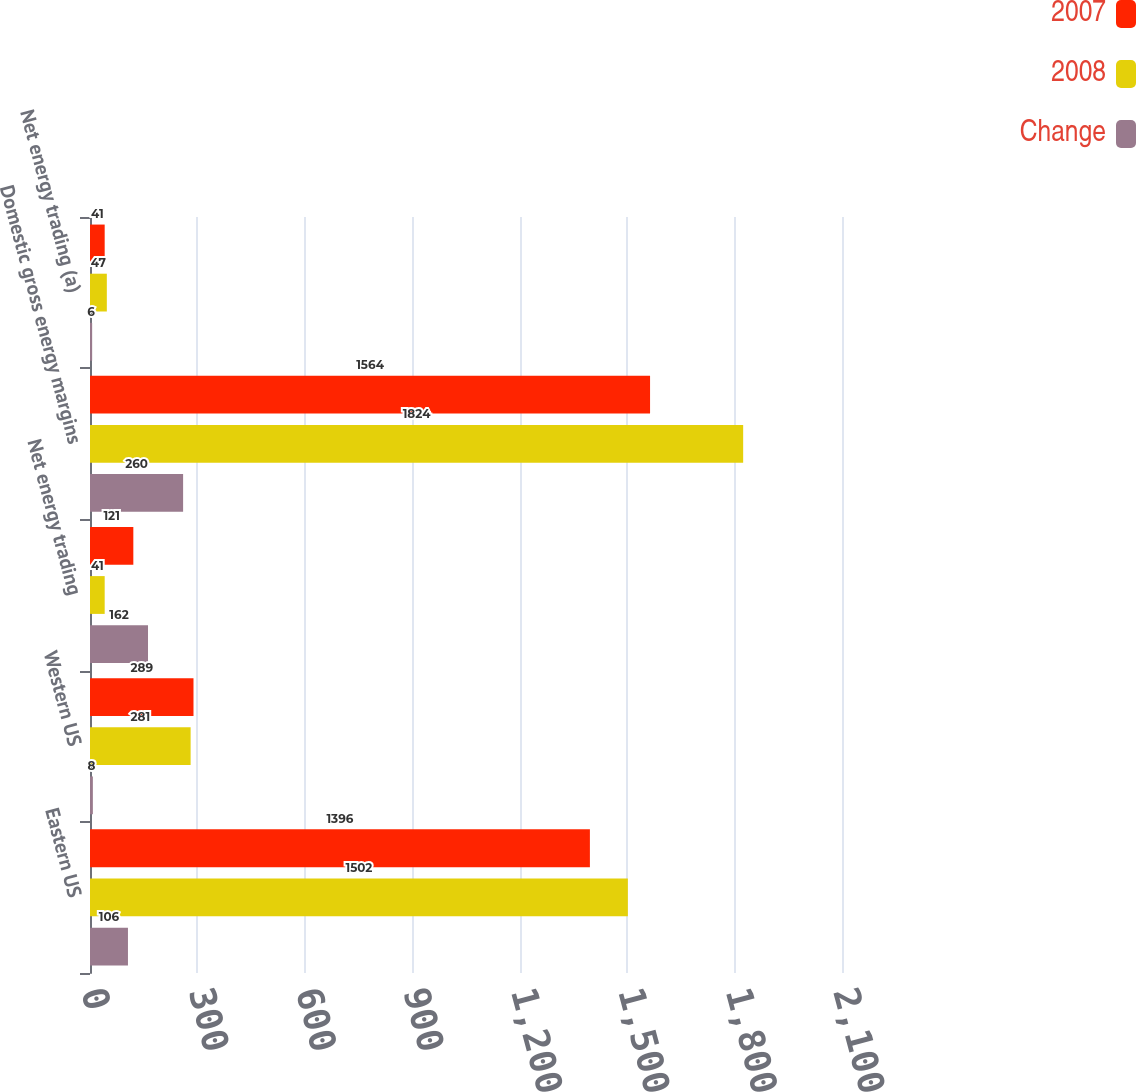Convert chart to OTSL. <chart><loc_0><loc_0><loc_500><loc_500><stacked_bar_chart><ecel><fcel>Eastern US<fcel>Western US<fcel>Net energy trading<fcel>Domestic gross energy margins<fcel>Net energy trading (a)<nl><fcel>2007<fcel>1396<fcel>289<fcel>121<fcel>1564<fcel>41<nl><fcel>2008<fcel>1502<fcel>281<fcel>41<fcel>1824<fcel>47<nl><fcel>Change<fcel>106<fcel>8<fcel>162<fcel>260<fcel>6<nl></chart> 